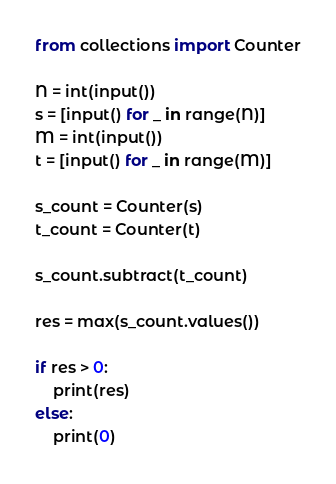Convert code to text. <code><loc_0><loc_0><loc_500><loc_500><_Python_>from collections import Counter

N = int(input())
s = [input() for _ in range(N)]
M = int(input())
t = [input() for _ in range(M)]

s_count = Counter(s)
t_count = Counter(t)

s_count.subtract(t_count)

res = max(s_count.values())

if res > 0:
    print(res)
else:
    print(0)</code> 